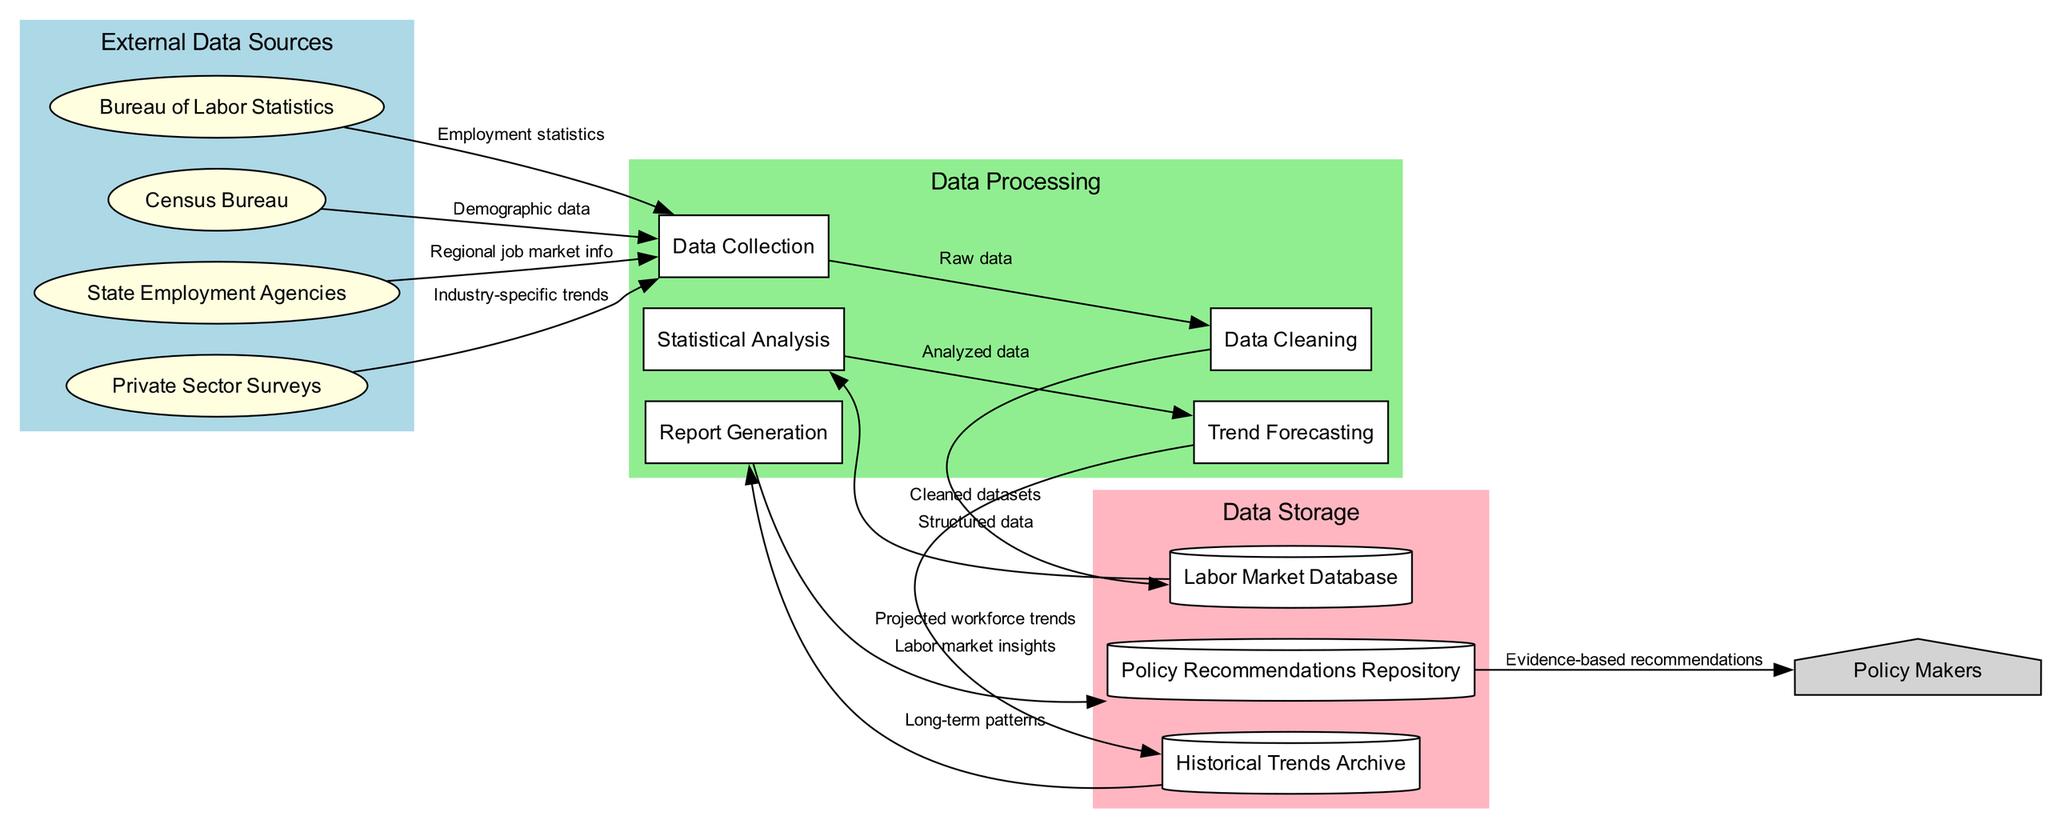What are the external entities involved in the labor market data supply chain? The diagram lists four external entities: Bureau of Labor Statistics, Census Bureau, State Employment Agencies, and Private Sector Surveys. These entities are represented as the primary sources of data that are collected.
Answer: Bureau of Labor Statistics, Census Bureau, State Employment Agencies, Private Sector Surveys How many processes are defined in the data flow diagram? The diagram specifies five processes involved in the labor market data processing. These processes are Data Collection, Data Cleaning, Statistical Analysis, Trend Forecasting, and Report Generation. Counting these processes gives a total of five.
Answer: Five What type of data does the Bureau of Labor Statistics provide to the collection process? According to the diagram, the Bureau of Labor Statistics supplies Employment statistics to the Data Collection process. This indicates the specific type of data being sourced from this external entity.
Answer: Employment statistics What is the final output delivered to policy makers? The last element in the diagram between Policy Recommendations Repository and Policy Makers indicates that Evidence-based recommendations are provided to the policy makers as the final output of the entire data flow process.
Answer: Evidence-based recommendations Which process follows Data Cleaning in the flow? In examining the flow of data from Data Cleaning, we see that it leads to the Labor Market Database. This indicates that cleaned datasets are stored, and the next process utilizing this data will occur after this step. The subsequent process following Data Cleaning is Statistical Analysis.
Answer: Statistical Analysis What is stored in the Historical Trends Archive? The data flows from Trend Forecasting to Historical Trends Archive show that Projected workforce trends are stored there. This indicates the type of data kept for future reference and analysis in the historical trends section.
Answer: Projected workforce trends How many data stores are in the data flow diagram? The diagram includes three data stores: Labor Market Database, Historical Trends Archive, and Policy Recommendations Repository. By counting these nodes, we find there are three distinct data storage areas.
Answer: Three Which external entity provides Industry-specific trends? According to the diagram, Industry-specific trends are provided by Private Sector Surveys, which is one of the identified external sources contributing to the data collection process.
Answer: Private Sector Surveys What type of insights are generated and stored in the Policy Recommendations Repository? The diagram indicates that the insights produced and stored in the Policy Recommendations Repository are labeled as Labor market insights. This emphasizes the nature of the analysis and recommendations derived from prior processes.
Answer: Labor market insights 